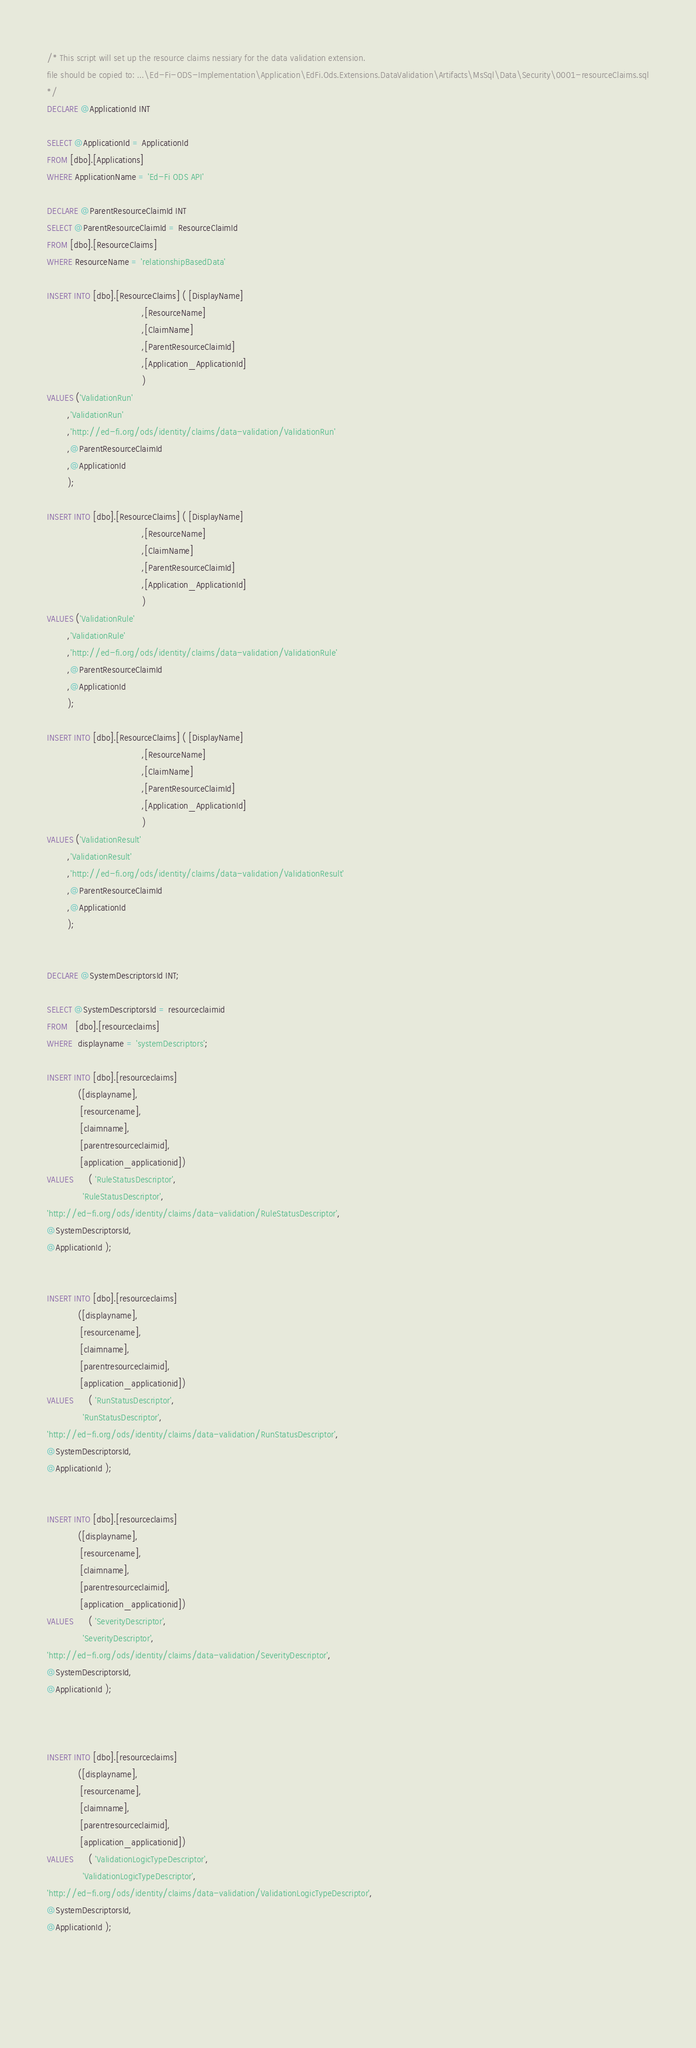<code> <loc_0><loc_0><loc_500><loc_500><_SQL_>/* This script will set up the resource claims nessiary for the data validation extension.
file should be copied to: ...\Ed-Fi-ODS-Implementation\Application\EdFi.Ods.Extensions.DataValidation\Artifacts\MsSql\Data\Security\0001-resourceClaims.sql
*/
DECLARE @ApplicationId INT
 
SELECT @ApplicationId = ApplicationId
FROM [dbo].[Applications]
WHERE ApplicationName = 'Ed-Fi ODS API'
  
DECLARE @ParentResourceClaimId INT
SELECT @ParentResourceClaimId = ResourceClaimId
FROM [dbo].[ResourceClaims]
WHERE ResourceName = 'relationshipBasedData'
 
INSERT INTO [dbo].[ResourceClaims] ( [DisplayName]
                                     ,[ResourceName]
                                     ,[ClaimName]     
                                     ,[ParentResourceClaimId]
                                     ,[Application_ApplicationId]
                                     )
VALUES ('ValidationRun'
        ,'ValidationRun'
        ,'http://ed-fi.org/ods/identity/claims/data-validation/ValidationRun'
        ,@ParentResourceClaimId
        ,@ApplicationId
        );
		
INSERT INTO [dbo].[ResourceClaims] ( [DisplayName]
                                     ,[ResourceName]
                                     ,[ClaimName]     
                                     ,[ParentResourceClaimId]
                                     ,[Application_ApplicationId]
                                     )
VALUES ('ValidationRule'
        ,'ValidationRule'
        ,'http://ed-fi.org/ods/identity/claims/data-validation/ValidationRule'
        ,@ParentResourceClaimId
        ,@ApplicationId
        );
		
INSERT INTO [dbo].[ResourceClaims] ( [DisplayName]
                                     ,[ResourceName]
                                     ,[ClaimName]     
                                     ,[ParentResourceClaimId]
                                     ,[Application_ApplicationId]
                                     )
VALUES ('ValidationResult'
        ,'ValidationResult'
        ,'http://ed-fi.org/ods/identity/claims/data-validation/ValidationResult'
        ,@ParentResourceClaimId
        ,@ApplicationId
        );
		

DECLARE @SystemDescriptorsId INT;
 
SELECT @SystemDescriptorsId = resourceclaimid
FROM   [dbo].[resourceclaims]
WHERE  displayname = 'systemDescriptors';
 
INSERT INTO [dbo].[resourceclaims]
            ([displayname],
             [resourcename],
             [claimname],
             [parentresourceclaimid],
             [application_applicationid])
VALUES      ( 'RuleStatusDescriptor',
              'RuleStatusDescriptor',
'http://ed-fi.org/ods/identity/claims/data-validation/RuleStatusDescriptor',
@SystemDescriptorsId,
@ApplicationId );
 

INSERT INTO [dbo].[resourceclaims]
            ([displayname],
             [resourcename],
             [claimname],
             [parentresourceclaimid],
             [application_applicationid])
VALUES      ( 'RunStatusDescriptor',
              'RunStatusDescriptor',
'http://ed-fi.org/ods/identity/claims/data-validation/RunStatusDescriptor',
@SystemDescriptorsId,
@ApplicationId );
 

INSERT INTO [dbo].[resourceclaims]
            ([displayname],
             [resourcename],
             [claimname],
             [parentresourceclaimid],
             [application_applicationid])
VALUES      ( 'SeverityDescriptor',
              'SeverityDescriptor',
'http://ed-fi.org/ods/identity/claims/data-validation/SeverityDescriptor',
@SystemDescriptorsId,
@ApplicationId );
 


INSERT INTO [dbo].[resourceclaims]
            ([displayname],
             [resourcename],
             [claimname],
             [parentresourceclaimid],
             [application_applicationid])
VALUES      ( 'ValidationLogicTypeDescriptor',
              'ValidationLogicTypeDescriptor',
'http://ed-fi.org/ods/identity/claims/data-validation/ValidationLogicTypeDescriptor',
@SystemDescriptorsId,
@ApplicationId );
 
						
						
						</code> 